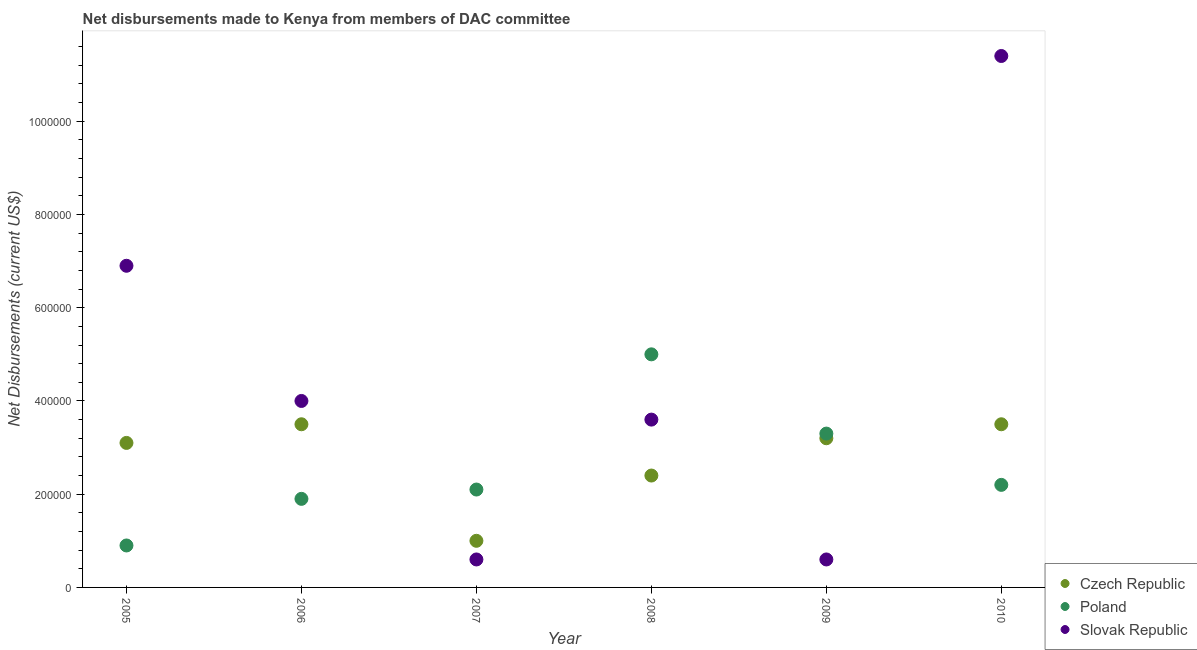What is the net disbursements made by poland in 2008?
Your answer should be compact. 5.00e+05. Across all years, what is the maximum net disbursements made by czech republic?
Offer a terse response. 3.50e+05. Across all years, what is the minimum net disbursements made by slovak republic?
Give a very brief answer. 6.00e+04. In which year was the net disbursements made by czech republic maximum?
Offer a terse response. 2006. What is the total net disbursements made by czech republic in the graph?
Give a very brief answer. 1.67e+06. What is the difference between the net disbursements made by slovak republic in 2007 and that in 2008?
Ensure brevity in your answer.  -3.00e+05. What is the difference between the net disbursements made by slovak republic in 2010 and the net disbursements made by poland in 2006?
Your response must be concise. 9.50e+05. What is the average net disbursements made by czech republic per year?
Provide a short and direct response. 2.78e+05. In the year 2006, what is the difference between the net disbursements made by slovak republic and net disbursements made by czech republic?
Offer a very short reply. 5.00e+04. In how many years, is the net disbursements made by slovak republic greater than 320000 US$?
Offer a terse response. 4. What is the ratio of the net disbursements made by slovak republic in 2006 to that in 2008?
Your response must be concise. 1.11. Is the net disbursements made by slovak republic in 2005 less than that in 2010?
Give a very brief answer. Yes. Is the difference between the net disbursements made by poland in 2005 and 2008 greater than the difference between the net disbursements made by czech republic in 2005 and 2008?
Make the answer very short. No. What is the difference between the highest and the lowest net disbursements made by poland?
Keep it short and to the point. 4.10e+05. In how many years, is the net disbursements made by czech republic greater than the average net disbursements made by czech republic taken over all years?
Provide a short and direct response. 4. Is the sum of the net disbursements made by poland in 2005 and 2010 greater than the maximum net disbursements made by slovak republic across all years?
Give a very brief answer. No. Does the net disbursements made by slovak republic monotonically increase over the years?
Provide a succinct answer. No. Is the net disbursements made by czech republic strictly less than the net disbursements made by slovak republic over the years?
Offer a very short reply. No. How many years are there in the graph?
Provide a short and direct response. 6. What is the difference between two consecutive major ticks on the Y-axis?
Offer a very short reply. 2.00e+05. Does the graph contain any zero values?
Provide a succinct answer. No. What is the title of the graph?
Offer a very short reply. Net disbursements made to Kenya from members of DAC committee. Does "Primary" appear as one of the legend labels in the graph?
Provide a succinct answer. No. What is the label or title of the X-axis?
Ensure brevity in your answer.  Year. What is the label or title of the Y-axis?
Ensure brevity in your answer.  Net Disbursements (current US$). What is the Net Disbursements (current US$) of Czech Republic in 2005?
Your answer should be very brief. 3.10e+05. What is the Net Disbursements (current US$) in Poland in 2005?
Offer a terse response. 9.00e+04. What is the Net Disbursements (current US$) in Slovak Republic in 2005?
Make the answer very short. 6.90e+05. What is the Net Disbursements (current US$) in Poland in 2006?
Your answer should be compact. 1.90e+05. What is the Net Disbursements (current US$) of Slovak Republic in 2006?
Your response must be concise. 4.00e+05. What is the Net Disbursements (current US$) of Czech Republic in 2007?
Give a very brief answer. 1.00e+05. What is the Net Disbursements (current US$) in Poland in 2007?
Ensure brevity in your answer.  2.10e+05. What is the Net Disbursements (current US$) of Slovak Republic in 2007?
Offer a terse response. 6.00e+04. What is the Net Disbursements (current US$) of Czech Republic in 2008?
Make the answer very short. 2.40e+05. What is the Net Disbursements (current US$) in Poland in 2008?
Give a very brief answer. 5.00e+05. What is the Net Disbursements (current US$) of Slovak Republic in 2008?
Offer a very short reply. 3.60e+05. What is the Net Disbursements (current US$) of Poland in 2009?
Ensure brevity in your answer.  3.30e+05. What is the Net Disbursements (current US$) of Slovak Republic in 2009?
Your answer should be compact. 6.00e+04. What is the Net Disbursements (current US$) in Slovak Republic in 2010?
Keep it short and to the point. 1.14e+06. Across all years, what is the maximum Net Disbursements (current US$) of Slovak Republic?
Make the answer very short. 1.14e+06. Across all years, what is the minimum Net Disbursements (current US$) of Czech Republic?
Your answer should be compact. 1.00e+05. Across all years, what is the minimum Net Disbursements (current US$) of Slovak Republic?
Make the answer very short. 6.00e+04. What is the total Net Disbursements (current US$) in Czech Republic in the graph?
Keep it short and to the point. 1.67e+06. What is the total Net Disbursements (current US$) in Poland in the graph?
Your response must be concise. 1.54e+06. What is the total Net Disbursements (current US$) in Slovak Republic in the graph?
Give a very brief answer. 2.71e+06. What is the difference between the Net Disbursements (current US$) in Poland in 2005 and that in 2006?
Ensure brevity in your answer.  -1.00e+05. What is the difference between the Net Disbursements (current US$) in Poland in 2005 and that in 2007?
Make the answer very short. -1.20e+05. What is the difference between the Net Disbursements (current US$) of Slovak Republic in 2005 and that in 2007?
Give a very brief answer. 6.30e+05. What is the difference between the Net Disbursements (current US$) of Czech Republic in 2005 and that in 2008?
Provide a succinct answer. 7.00e+04. What is the difference between the Net Disbursements (current US$) of Poland in 2005 and that in 2008?
Make the answer very short. -4.10e+05. What is the difference between the Net Disbursements (current US$) in Slovak Republic in 2005 and that in 2008?
Your answer should be compact. 3.30e+05. What is the difference between the Net Disbursements (current US$) of Czech Republic in 2005 and that in 2009?
Provide a succinct answer. -10000. What is the difference between the Net Disbursements (current US$) of Slovak Republic in 2005 and that in 2009?
Provide a succinct answer. 6.30e+05. What is the difference between the Net Disbursements (current US$) of Poland in 2005 and that in 2010?
Offer a terse response. -1.30e+05. What is the difference between the Net Disbursements (current US$) of Slovak Republic in 2005 and that in 2010?
Make the answer very short. -4.50e+05. What is the difference between the Net Disbursements (current US$) in Poland in 2006 and that in 2008?
Give a very brief answer. -3.10e+05. What is the difference between the Net Disbursements (current US$) of Slovak Republic in 2006 and that in 2008?
Provide a succinct answer. 4.00e+04. What is the difference between the Net Disbursements (current US$) of Slovak Republic in 2006 and that in 2009?
Offer a very short reply. 3.40e+05. What is the difference between the Net Disbursements (current US$) in Czech Republic in 2006 and that in 2010?
Provide a succinct answer. 0. What is the difference between the Net Disbursements (current US$) in Slovak Republic in 2006 and that in 2010?
Provide a short and direct response. -7.40e+05. What is the difference between the Net Disbursements (current US$) in Czech Republic in 2007 and that in 2008?
Provide a short and direct response. -1.40e+05. What is the difference between the Net Disbursements (current US$) of Slovak Republic in 2007 and that in 2008?
Give a very brief answer. -3.00e+05. What is the difference between the Net Disbursements (current US$) of Czech Republic in 2007 and that in 2009?
Provide a succinct answer. -2.20e+05. What is the difference between the Net Disbursements (current US$) in Poland in 2007 and that in 2009?
Your response must be concise. -1.20e+05. What is the difference between the Net Disbursements (current US$) of Poland in 2007 and that in 2010?
Provide a succinct answer. -10000. What is the difference between the Net Disbursements (current US$) of Slovak Republic in 2007 and that in 2010?
Your response must be concise. -1.08e+06. What is the difference between the Net Disbursements (current US$) of Czech Republic in 2008 and that in 2009?
Offer a terse response. -8.00e+04. What is the difference between the Net Disbursements (current US$) of Slovak Republic in 2008 and that in 2009?
Provide a succinct answer. 3.00e+05. What is the difference between the Net Disbursements (current US$) of Czech Republic in 2008 and that in 2010?
Your response must be concise. -1.10e+05. What is the difference between the Net Disbursements (current US$) of Slovak Republic in 2008 and that in 2010?
Ensure brevity in your answer.  -7.80e+05. What is the difference between the Net Disbursements (current US$) of Czech Republic in 2009 and that in 2010?
Make the answer very short. -3.00e+04. What is the difference between the Net Disbursements (current US$) of Slovak Republic in 2009 and that in 2010?
Your answer should be compact. -1.08e+06. What is the difference between the Net Disbursements (current US$) in Czech Republic in 2005 and the Net Disbursements (current US$) in Poland in 2006?
Your response must be concise. 1.20e+05. What is the difference between the Net Disbursements (current US$) in Poland in 2005 and the Net Disbursements (current US$) in Slovak Republic in 2006?
Make the answer very short. -3.10e+05. What is the difference between the Net Disbursements (current US$) in Poland in 2005 and the Net Disbursements (current US$) in Slovak Republic in 2007?
Your answer should be compact. 3.00e+04. What is the difference between the Net Disbursements (current US$) in Czech Republic in 2005 and the Net Disbursements (current US$) in Slovak Republic in 2008?
Ensure brevity in your answer.  -5.00e+04. What is the difference between the Net Disbursements (current US$) in Czech Republic in 2005 and the Net Disbursements (current US$) in Poland in 2010?
Keep it short and to the point. 9.00e+04. What is the difference between the Net Disbursements (current US$) of Czech Republic in 2005 and the Net Disbursements (current US$) of Slovak Republic in 2010?
Provide a short and direct response. -8.30e+05. What is the difference between the Net Disbursements (current US$) of Poland in 2005 and the Net Disbursements (current US$) of Slovak Republic in 2010?
Provide a succinct answer. -1.05e+06. What is the difference between the Net Disbursements (current US$) of Czech Republic in 2006 and the Net Disbursements (current US$) of Poland in 2007?
Your answer should be very brief. 1.40e+05. What is the difference between the Net Disbursements (current US$) of Czech Republic in 2006 and the Net Disbursements (current US$) of Slovak Republic in 2007?
Provide a succinct answer. 2.90e+05. What is the difference between the Net Disbursements (current US$) of Czech Republic in 2006 and the Net Disbursements (current US$) of Poland in 2009?
Provide a succinct answer. 2.00e+04. What is the difference between the Net Disbursements (current US$) of Czech Republic in 2006 and the Net Disbursements (current US$) of Poland in 2010?
Provide a short and direct response. 1.30e+05. What is the difference between the Net Disbursements (current US$) of Czech Republic in 2006 and the Net Disbursements (current US$) of Slovak Republic in 2010?
Your answer should be very brief. -7.90e+05. What is the difference between the Net Disbursements (current US$) of Poland in 2006 and the Net Disbursements (current US$) of Slovak Republic in 2010?
Your response must be concise. -9.50e+05. What is the difference between the Net Disbursements (current US$) of Czech Republic in 2007 and the Net Disbursements (current US$) of Poland in 2008?
Offer a very short reply. -4.00e+05. What is the difference between the Net Disbursements (current US$) of Poland in 2007 and the Net Disbursements (current US$) of Slovak Republic in 2008?
Offer a terse response. -1.50e+05. What is the difference between the Net Disbursements (current US$) in Czech Republic in 2007 and the Net Disbursements (current US$) in Slovak Republic in 2009?
Make the answer very short. 4.00e+04. What is the difference between the Net Disbursements (current US$) in Poland in 2007 and the Net Disbursements (current US$) in Slovak Republic in 2009?
Provide a short and direct response. 1.50e+05. What is the difference between the Net Disbursements (current US$) of Czech Republic in 2007 and the Net Disbursements (current US$) of Slovak Republic in 2010?
Give a very brief answer. -1.04e+06. What is the difference between the Net Disbursements (current US$) in Poland in 2007 and the Net Disbursements (current US$) in Slovak Republic in 2010?
Give a very brief answer. -9.30e+05. What is the difference between the Net Disbursements (current US$) of Czech Republic in 2008 and the Net Disbursements (current US$) of Poland in 2009?
Offer a very short reply. -9.00e+04. What is the difference between the Net Disbursements (current US$) in Czech Republic in 2008 and the Net Disbursements (current US$) in Slovak Republic in 2009?
Keep it short and to the point. 1.80e+05. What is the difference between the Net Disbursements (current US$) in Czech Republic in 2008 and the Net Disbursements (current US$) in Poland in 2010?
Offer a terse response. 2.00e+04. What is the difference between the Net Disbursements (current US$) in Czech Republic in 2008 and the Net Disbursements (current US$) in Slovak Republic in 2010?
Ensure brevity in your answer.  -9.00e+05. What is the difference between the Net Disbursements (current US$) of Poland in 2008 and the Net Disbursements (current US$) of Slovak Republic in 2010?
Ensure brevity in your answer.  -6.40e+05. What is the difference between the Net Disbursements (current US$) in Czech Republic in 2009 and the Net Disbursements (current US$) in Slovak Republic in 2010?
Ensure brevity in your answer.  -8.20e+05. What is the difference between the Net Disbursements (current US$) in Poland in 2009 and the Net Disbursements (current US$) in Slovak Republic in 2010?
Make the answer very short. -8.10e+05. What is the average Net Disbursements (current US$) in Czech Republic per year?
Your answer should be very brief. 2.78e+05. What is the average Net Disbursements (current US$) of Poland per year?
Offer a very short reply. 2.57e+05. What is the average Net Disbursements (current US$) in Slovak Republic per year?
Ensure brevity in your answer.  4.52e+05. In the year 2005, what is the difference between the Net Disbursements (current US$) in Czech Republic and Net Disbursements (current US$) in Slovak Republic?
Your answer should be compact. -3.80e+05. In the year 2005, what is the difference between the Net Disbursements (current US$) of Poland and Net Disbursements (current US$) of Slovak Republic?
Provide a short and direct response. -6.00e+05. In the year 2006, what is the difference between the Net Disbursements (current US$) of Czech Republic and Net Disbursements (current US$) of Slovak Republic?
Provide a short and direct response. -5.00e+04. In the year 2007, what is the difference between the Net Disbursements (current US$) in Czech Republic and Net Disbursements (current US$) in Slovak Republic?
Provide a short and direct response. 4.00e+04. In the year 2008, what is the difference between the Net Disbursements (current US$) of Poland and Net Disbursements (current US$) of Slovak Republic?
Offer a terse response. 1.40e+05. In the year 2009, what is the difference between the Net Disbursements (current US$) of Czech Republic and Net Disbursements (current US$) of Slovak Republic?
Provide a succinct answer. 2.60e+05. In the year 2010, what is the difference between the Net Disbursements (current US$) of Czech Republic and Net Disbursements (current US$) of Poland?
Provide a short and direct response. 1.30e+05. In the year 2010, what is the difference between the Net Disbursements (current US$) in Czech Republic and Net Disbursements (current US$) in Slovak Republic?
Your answer should be compact. -7.90e+05. In the year 2010, what is the difference between the Net Disbursements (current US$) in Poland and Net Disbursements (current US$) in Slovak Republic?
Offer a very short reply. -9.20e+05. What is the ratio of the Net Disbursements (current US$) in Czech Republic in 2005 to that in 2006?
Offer a terse response. 0.89. What is the ratio of the Net Disbursements (current US$) in Poland in 2005 to that in 2006?
Your answer should be very brief. 0.47. What is the ratio of the Net Disbursements (current US$) of Slovak Republic in 2005 to that in 2006?
Offer a terse response. 1.73. What is the ratio of the Net Disbursements (current US$) in Czech Republic in 2005 to that in 2007?
Provide a succinct answer. 3.1. What is the ratio of the Net Disbursements (current US$) in Poland in 2005 to that in 2007?
Keep it short and to the point. 0.43. What is the ratio of the Net Disbursements (current US$) in Slovak Republic in 2005 to that in 2007?
Your response must be concise. 11.5. What is the ratio of the Net Disbursements (current US$) of Czech Republic in 2005 to that in 2008?
Your response must be concise. 1.29. What is the ratio of the Net Disbursements (current US$) of Poland in 2005 to that in 2008?
Keep it short and to the point. 0.18. What is the ratio of the Net Disbursements (current US$) of Slovak Republic in 2005 to that in 2008?
Give a very brief answer. 1.92. What is the ratio of the Net Disbursements (current US$) in Czech Republic in 2005 to that in 2009?
Ensure brevity in your answer.  0.97. What is the ratio of the Net Disbursements (current US$) in Poland in 2005 to that in 2009?
Keep it short and to the point. 0.27. What is the ratio of the Net Disbursements (current US$) of Slovak Republic in 2005 to that in 2009?
Your answer should be very brief. 11.5. What is the ratio of the Net Disbursements (current US$) in Czech Republic in 2005 to that in 2010?
Ensure brevity in your answer.  0.89. What is the ratio of the Net Disbursements (current US$) of Poland in 2005 to that in 2010?
Keep it short and to the point. 0.41. What is the ratio of the Net Disbursements (current US$) in Slovak Republic in 2005 to that in 2010?
Your answer should be compact. 0.61. What is the ratio of the Net Disbursements (current US$) of Czech Republic in 2006 to that in 2007?
Your answer should be compact. 3.5. What is the ratio of the Net Disbursements (current US$) of Poland in 2006 to that in 2007?
Ensure brevity in your answer.  0.9. What is the ratio of the Net Disbursements (current US$) in Slovak Republic in 2006 to that in 2007?
Make the answer very short. 6.67. What is the ratio of the Net Disbursements (current US$) of Czech Republic in 2006 to that in 2008?
Your answer should be very brief. 1.46. What is the ratio of the Net Disbursements (current US$) in Poland in 2006 to that in 2008?
Provide a short and direct response. 0.38. What is the ratio of the Net Disbursements (current US$) in Czech Republic in 2006 to that in 2009?
Your answer should be compact. 1.09. What is the ratio of the Net Disbursements (current US$) in Poland in 2006 to that in 2009?
Give a very brief answer. 0.58. What is the ratio of the Net Disbursements (current US$) in Slovak Republic in 2006 to that in 2009?
Offer a terse response. 6.67. What is the ratio of the Net Disbursements (current US$) in Poland in 2006 to that in 2010?
Make the answer very short. 0.86. What is the ratio of the Net Disbursements (current US$) in Slovak Republic in 2006 to that in 2010?
Provide a short and direct response. 0.35. What is the ratio of the Net Disbursements (current US$) of Czech Republic in 2007 to that in 2008?
Make the answer very short. 0.42. What is the ratio of the Net Disbursements (current US$) in Poland in 2007 to that in 2008?
Provide a short and direct response. 0.42. What is the ratio of the Net Disbursements (current US$) of Czech Republic in 2007 to that in 2009?
Give a very brief answer. 0.31. What is the ratio of the Net Disbursements (current US$) of Poland in 2007 to that in 2009?
Your response must be concise. 0.64. What is the ratio of the Net Disbursements (current US$) of Czech Republic in 2007 to that in 2010?
Your answer should be compact. 0.29. What is the ratio of the Net Disbursements (current US$) of Poland in 2007 to that in 2010?
Offer a very short reply. 0.95. What is the ratio of the Net Disbursements (current US$) of Slovak Republic in 2007 to that in 2010?
Give a very brief answer. 0.05. What is the ratio of the Net Disbursements (current US$) in Poland in 2008 to that in 2009?
Make the answer very short. 1.52. What is the ratio of the Net Disbursements (current US$) in Slovak Republic in 2008 to that in 2009?
Ensure brevity in your answer.  6. What is the ratio of the Net Disbursements (current US$) in Czech Republic in 2008 to that in 2010?
Your response must be concise. 0.69. What is the ratio of the Net Disbursements (current US$) of Poland in 2008 to that in 2010?
Keep it short and to the point. 2.27. What is the ratio of the Net Disbursements (current US$) of Slovak Republic in 2008 to that in 2010?
Your response must be concise. 0.32. What is the ratio of the Net Disbursements (current US$) of Czech Republic in 2009 to that in 2010?
Offer a terse response. 0.91. What is the ratio of the Net Disbursements (current US$) in Poland in 2009 to that in 2010?
Make the answer very short. 1.5. What is the ratio of the Net Disbursements (current US$) of Slovak Republic in 2009 to that in 2010?
Your answer should be compact. 0.05. What is the difference between the highest and the second highest Net Disbursements (current US$) in Czech Republic?
Ensure brevity in your answer.  0. What is the difference between the highest and the lowest Net Disbursements (current US$) in Poland?
Your response must be concise. 4.10e+05. What is the difference between the highest and the lowest Net Disbursements (current US$) of Slovak Republic?
Your answer should be very brief. 1.08e+06. 